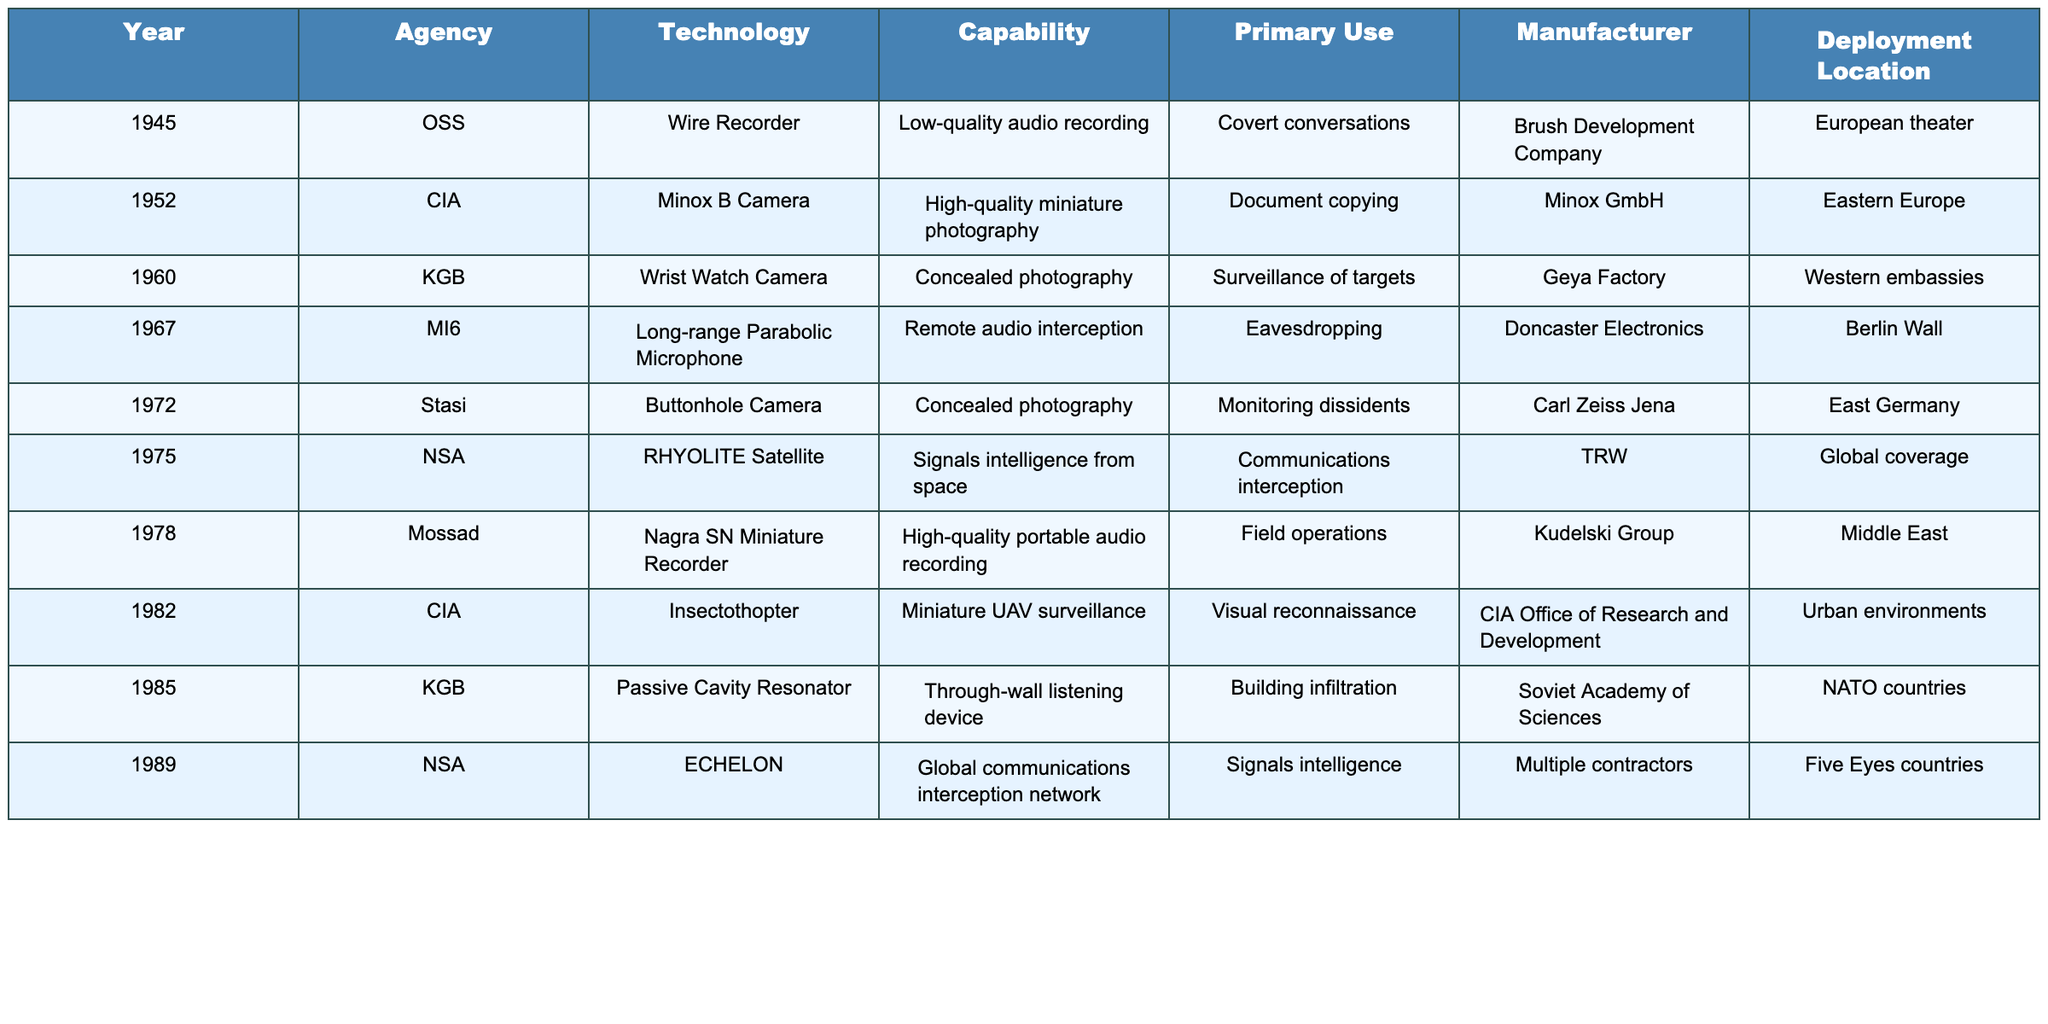What technology was used by the CIA in 1982? According to the table, the CIA deployed the Insectothopter in 1982, which is a miniature UAV surveillance technology.
Answer: Insectothopter Which agency operated the RHYOLITE satellite? The table specifies that the National Security Agency (NSA) was responsible for operating the RHYOLITE satellite, which was used for signals intelligence from space.
Answer: NSA What was the primary use of the Long-range Parabolic Microphone? The primary use of the Long-range Parabolic Microphone, as stated in the table, was for eavesdropping.
Answer: Eavesdropping How many types of concealed photography devices are mentioned in the table? The table lists 3 devices designed for concealed photography: the Minox B Camera, the Wrist Watch Camera, and the Buttonhole Camera.
Answer: 3 Which technology was deployed globally, according to the table? The ECHELON technology was mentioned as being deployed globally, serving as a global communications interception network.
Answer: ECHELON Were any of the technologies used by the KGB utilized for building infiltration purposes? Yes, the table indicates that the Passive Cavity Resonator was used by the KGB as a through-wall listening device, which facilitates building infiltration.
Answer: Yes What is the difference in deployment years between the Nagra SN Miniature Recorder and the Insectothopter? The Nagra SN Miniature Recorder was deployed in 1978, while the Insectothopter was deployed in 1982. The difference between these years is 4 years (1982 - 1978).
Answer: 4 years Identify the manufacturer for the Buttonhole Camera. The manufacturer of the Buttonhole Camera, as shown in the table, was Carl Zeiss Jena.
Answer: Carl Zeiss Jena Which agency had the earliest entry in the table, and what was the technology? The Office of Strategic Services (OSS) had the earliest entry in 1945, using the Wire Recorder technology.
Answer: OSS, Wire Recorder Which technology listed in the table is specifically mentioned as being used for monitoring dissidents? The Buttonhole Camera is specifically identified in the table as being used for monitoring dissidents by the Stasi.
Answer: Buttonhole Camera How many technologies were manufactured by organizations based in Europe? The technologies manufactured by European organizations according to the table are the Wire Recorder (Brush Development Company), Minox B Camera (Minox GmbH), Long-range Parabolic Microphone (Doncaster Electronics), Buttonhole Camera (Carl Zeiss Jena), Nagra SN Miniature Recorder (Kudelski Group), and Passive Cavity Resonator (Soviet Academy of Sciences). That totals to 6 technologies.
Answer: 6 